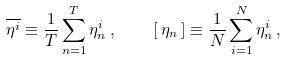Convert formula to latex. <formula><loc_0><loc_0><loc_500><loc_500>\overline { \eta ^ { i } } \equiv \frac { 1 } { T } \sum _ { n = 1 } ^ { T } \eta _ { n } ^ { i } \, , \quad [ \, \eta _ { n } \, ] \equiv \frac { 1 } { N } \sum _ { i = 1 } ^ { N } \eta _ { n } ^ { i } \, ,</formula> 